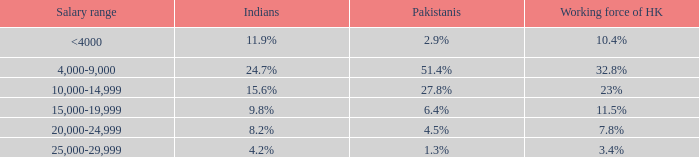What is the salary range if the percentage of indians is 8.2%? 20,000-24,999. 